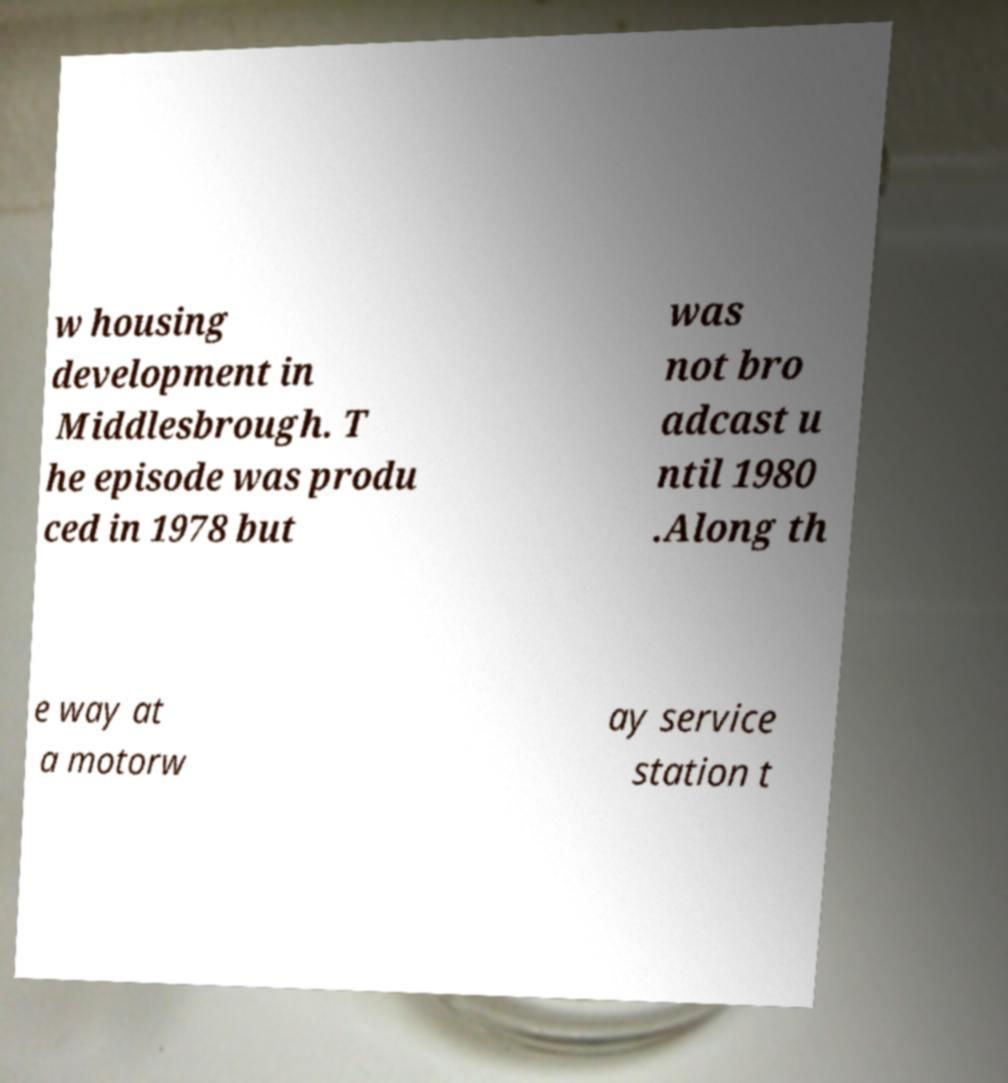Can you accurately transcribe the text from the provided image for me? w housing development in Middlesbrough. T he episode was produ ced in 1978 but was not bro adcast u ntil 1980 .Along th e way at a motorw ay service station t 